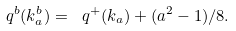Convert formula to latex. <formula><loc_0><loc_0><loc_500><loc_500>\ q ^ { b } ( k ^ { b } _ { a } ) = \ q ^ { + } ( k _ { a } ) + ( a ^ { 2 } - 1 ) / 8 .</formula> 